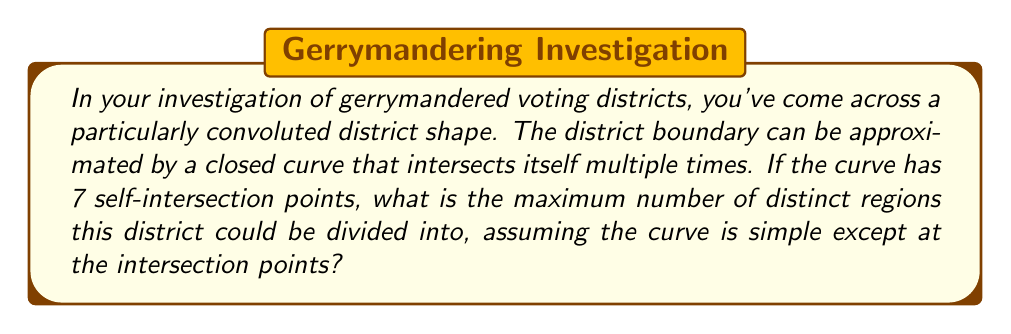Could you help me with this problem? To solve this problem, we need to apply concepts from planar graph theory and topology. The self-intersecting curve can be thought of as a planar graph, where the self-intersection points are vertices.

1) First, recall Euler's formula for planar graphs:
   $$ V - E + F = 2 $$
   where V is the number of vertices, E is the number of edges, and F is the number of faces (including the exterior face).

2) In our case, we have 7 self-intersection points, so V = 7.

3) At each intersection point, four edges meet. Each edge connects two vertices, so we can calculate the number of edges as:
   $$ E = \frac{4V}{2} = 2V = 2(7) = 14 $$

4) Now we can use Euler's formula to find F:
   $$ 7 - 14 + F = 2 $$
   $$ F = 9 $$

5) However, this F includes the exterior face. The number of interior regions (which correspond to the distinct areas of the district) is F - 1.

6) Therefore, the maximum number of distinct regions is:
   $$ 9 - 1 = 8 $$

This result assumes that the curve is arranged in the most complex way possible, maximizing the number of regions created.
Answer: The maximum number of distinct regions is 8. 